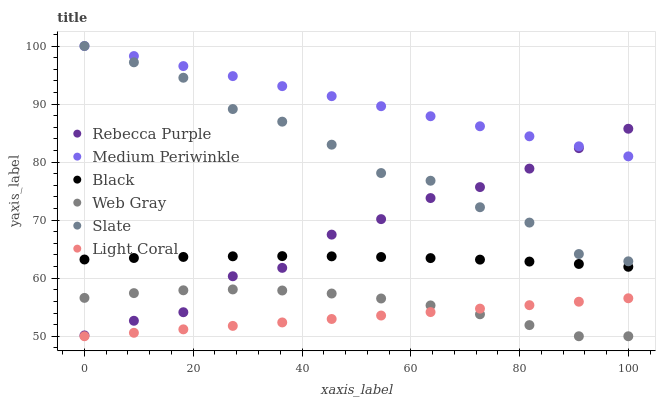Does Light Coral have the minimum area under the curve?
Answer yes or no. Yes. Does Medium Periwinkle have the maximum area under the curve?
Answer yes or no. Yes. Does Slate have the minimum area under the curve?
Answer yes or no. No. Does Slate have the maximum area under the curve?
Answer yes or no. No. Is Light Coral the smoothest?
Answer yes or no. Yes. Is Slate the roughest?
Answer yes or no. Yes. Is Medium Periwinkle the smoothest?
Answer yes or no. No. Is Medium Periwinkle the roughest?
Answer yes or no. No. Does Web Gray have the lowest value?
Answer yes or no. Yes. Does Slate have the lowest value?
Answer yes or no. No. Does Medium Periwinkle have the highest value?
Answer yes or no. Yes. Does Light Coral have the highest value?
Answer yes or no. No. Is Light Coral less than Medium Periwinkle?
Answer yes or no. Yes. Is Slate greater than Black?
Answer yes or no. Yes. Does Rebecca Purple intersect Web Gray?
Answer yes or no. Yes. Is Rebecca Purple less than Web Gray?
Answer yes or no. No. Is Rebecca Purple greater than Web Gray?
Answer yes or no. No. Does Light Coral intersect Medium Periwinkle?
Answer yes or no. No. 